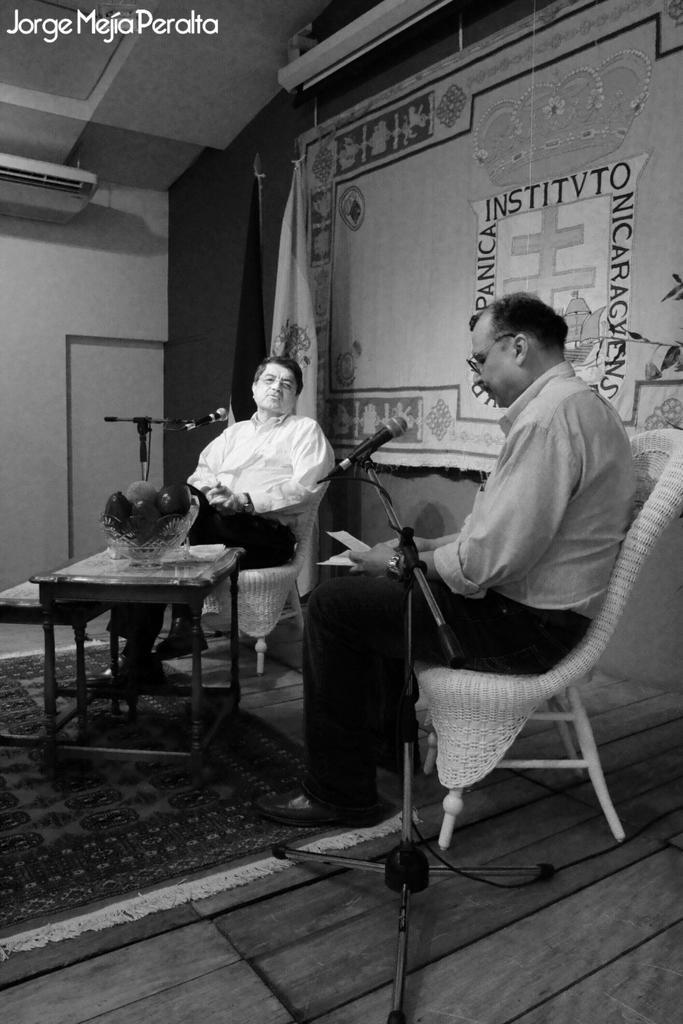Could you give a brief overview of what you see in this image? In the image we can see there are two men who are sitting on chair and in front of them there is a table on which there is a bowl and fruits are kept in it and the image is a black and white picture. 